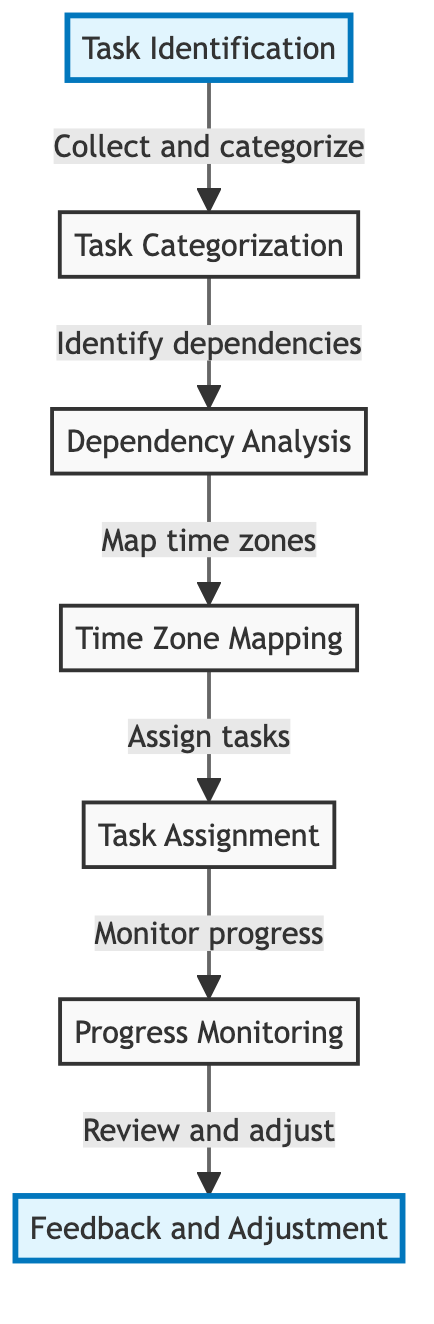What's the first node in the diagram? The first node is labeled "Task Identification," indicating the starting point of the workflow process.
Answer: Task Identification How many nodes are present in the diagram? There are a total of seven nodes listed, each representing a distinct step in the workflow.
Answer: Seven What is the relationship between "Task Identification" and "Task Categorization"? The relationship is indicated by a directed arrow showing that "Task Identification" leads to "Task Categorization," meaning that identifying tasks precedes their categorization.
Answer: Leads to Which node has the last connection in the workflow? The last connection in the workflow is to the node labeled "Feedback and Adjustment," which follows "Progress Monitoring."
Answer: Feedback and Adjustment What action follows "Time Zone Mapping"? The action that follows "Time Zone Mapping" is "Task Assignment," indicating the next step after mapping out the time zones.
Answer: Task Assignment If you wanted to know the main steps after identifying tasks, which node should you look at? After identifying tasks, the next node to look at is "Task Categorization," which follows directly from "Task Identification" based on the directed flow.
Answer: Task Categorization What are the primary responsibilities contained within the workflow structure? The primary responsibilities indicated by the node labels reflect identifying, categorizing, analyzing dependencies, mapping time zones, assigning tasks, monitoring progress, and adjusting based on feedback.
Answer: Identifying, categorizing, analyzing, mapping, assigning, monitoring, adjusting How does "Dependency Analysis" relate to the overall workflow? "Dependency Analysis" is a critical step as it links the task categorization to time zone mapping, indicating that understanding dependencies is essential before moving to the next step in the workflow.
Answer: Essential step What is the significance of the highlighted nodes in the diagram? The highlighted nodes represent the starting and concluding parts of the workflow, marking the entry and exit points of the process.
Answer: Entry and exit points 